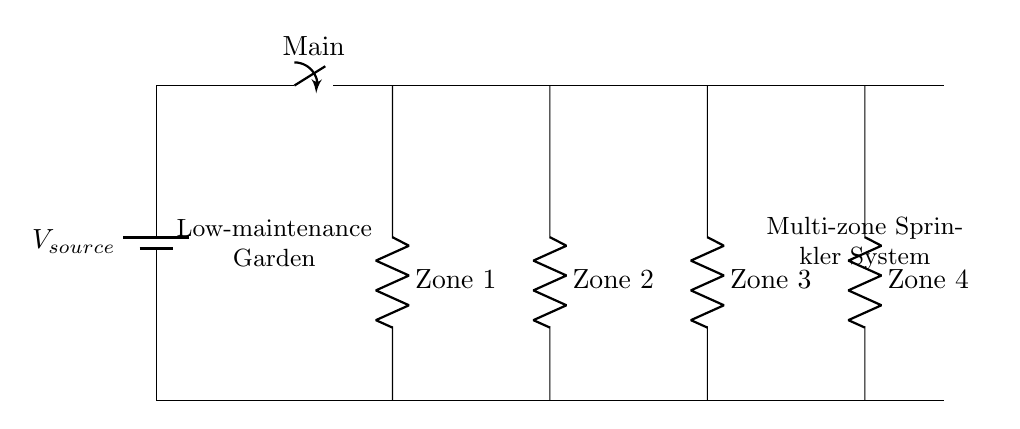What is the total number of zones in this sprinkler system? The diagram shows four resistors labeled as Zone 1, Zone 2, Zone 3, and Zone 4, indicating there are four zones in total.
Answer: four zones What is the function of the switch labeled "Main"? The switch labeled "Main" serves to control the overall operation of the circuit, allowing all zones to turn on or off simultaneously when the switch is activated or deactivated.
Answer: control What type of circuit configuration is used in this design? The circuit is designed in a parallel configuration, which allows each zone to operate independently while sharing the same voltage source.
Answer: parallel Which component provides the power in this circuit? The battery is the component that provides the power supply, as indicated by the label $V_{source}$ at the top of the diagram.
Answer: battery What description can you give to the area annotated as "Low-maintenance Garden"? This text in the diagram suggests that the circuit is designed for a garden that requires minimal upkeep, implying that the sprinkler system will automate watering.
Answer: low-maintenance garden How does each zone affect the overall current flow in this circuit? In a parallel circuit, each zone has its own resistor, and the overall current is the sum of the currents through each zone, meaning that activating more zones will increase the total current in the circuit.
Answer: independent What is the purpose of the resistors in each zone? The resistors in each zone represent the individual watering zones' resistance, allowing adjustments to the flow rate and pressure in each section of the garden.
Answer: flow control 